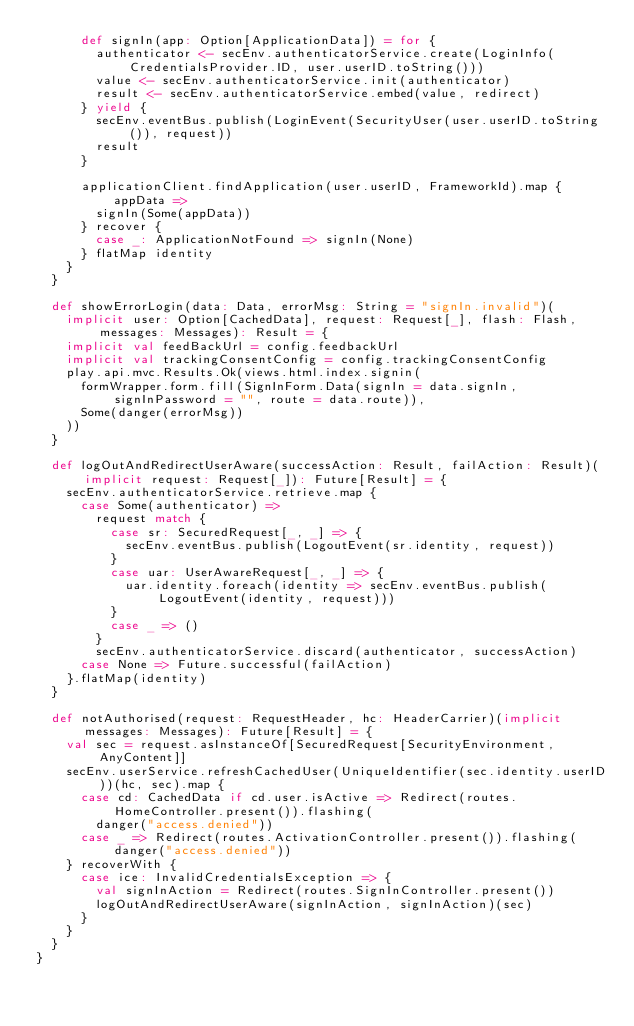<code> <loc_0><loc_0><loc_500><loc_500><_Scala_>      def signIn(app: Option[ApplicationData]) = for {
        authenticator <- secEnv.authenticatorService.create(LoginInfo(CredentialsProvider.ID, user.userID.toString()))
        value <- secEnv.authenticatorService.init(authenticator)
        result <- secEnv.authenticatorService.embed(value, redirect)
      } yield {
        secEnv.eventBus.publish(LoginEvent(SecurityUser(user.userID.toString()), request))
        result
      }

      applicationClient.findApplication(user.userID, FrameworkId).map { appData =>
        signIn(Some(appData))
      } recover {
        case _: ApplicationNotFound => signIn(None)
      } flatMap identity
    }
  }

  def showErrorLogin(data: Data, errorMsg: String = "signIn.invalid")(
    implicit user: Option[CachedData], request: Request[_], flash: Flash, messages: Messages): Result = {
    implicit val feedBackUrl = config.feedbackUrl
    implicit val trackingConsentConfig = config.trackingConsentConfig
    play.api.mvc.Results.Ok(views.html.index.signin(
      formWrapper.form.fill(SignInForm.Data(signIn = data.signIn, signInPassword = "", route = data.route)),
      Some(danger(errorMsg))
    ))
  }

  def logOutAndRedirectUserAware(successAction: Result, failAction: Result)(implicit request: Request[_]): Future[Result] = {
    secEnv.authenticatorService.retrieve.map {
      case Some(authenticator) =>
        request match {
          case sr: SecuredRequest[_, _] => {
            secEnv.eventBus.publish(LogoutEvent(sr.identity, request))
          }
          case uar: UserAwareRequest[_, _] => {
            uar.identity.foreach(identity => secEnv.eventBus.publish(LogoutEvent(identity, request)))
          }
          case _ => ()
        }
        secEnv.authenticatorService.discard(authenticator, successAction)
      case None => Future.successful(failAction)
    }.flatMap(identity)
  }

  def notAuthorised(request: RequestHeader, hc: HeaderCarrier)(implicit messages: Messages): Future[Result] = {
    val sec = request.asInstanceOf[SecuredRequest[SecurityEnvironment, AnyContent]]
    secEnv.userService.refreshCachedUser(UniqueIdentifier(sec.identity.userID))(hc, sec).map {
      case cd: CachedData if cd.user.isActive => Redirect(routes.HomeController.present()).flashing(
        danger("access.denied"))
      case _ => Redirect(routes.ActivationController.present()).flashing(danger("access.denied"))
    } recoverWith {
      case ice: InvalidCredentialsException => {
        val signInAction = Redirect(routes.SignInController.present())
        logOutAndRedirectUserAware(signInAction, signInAction)(sec)
      }
    }
  }
}
</code> 